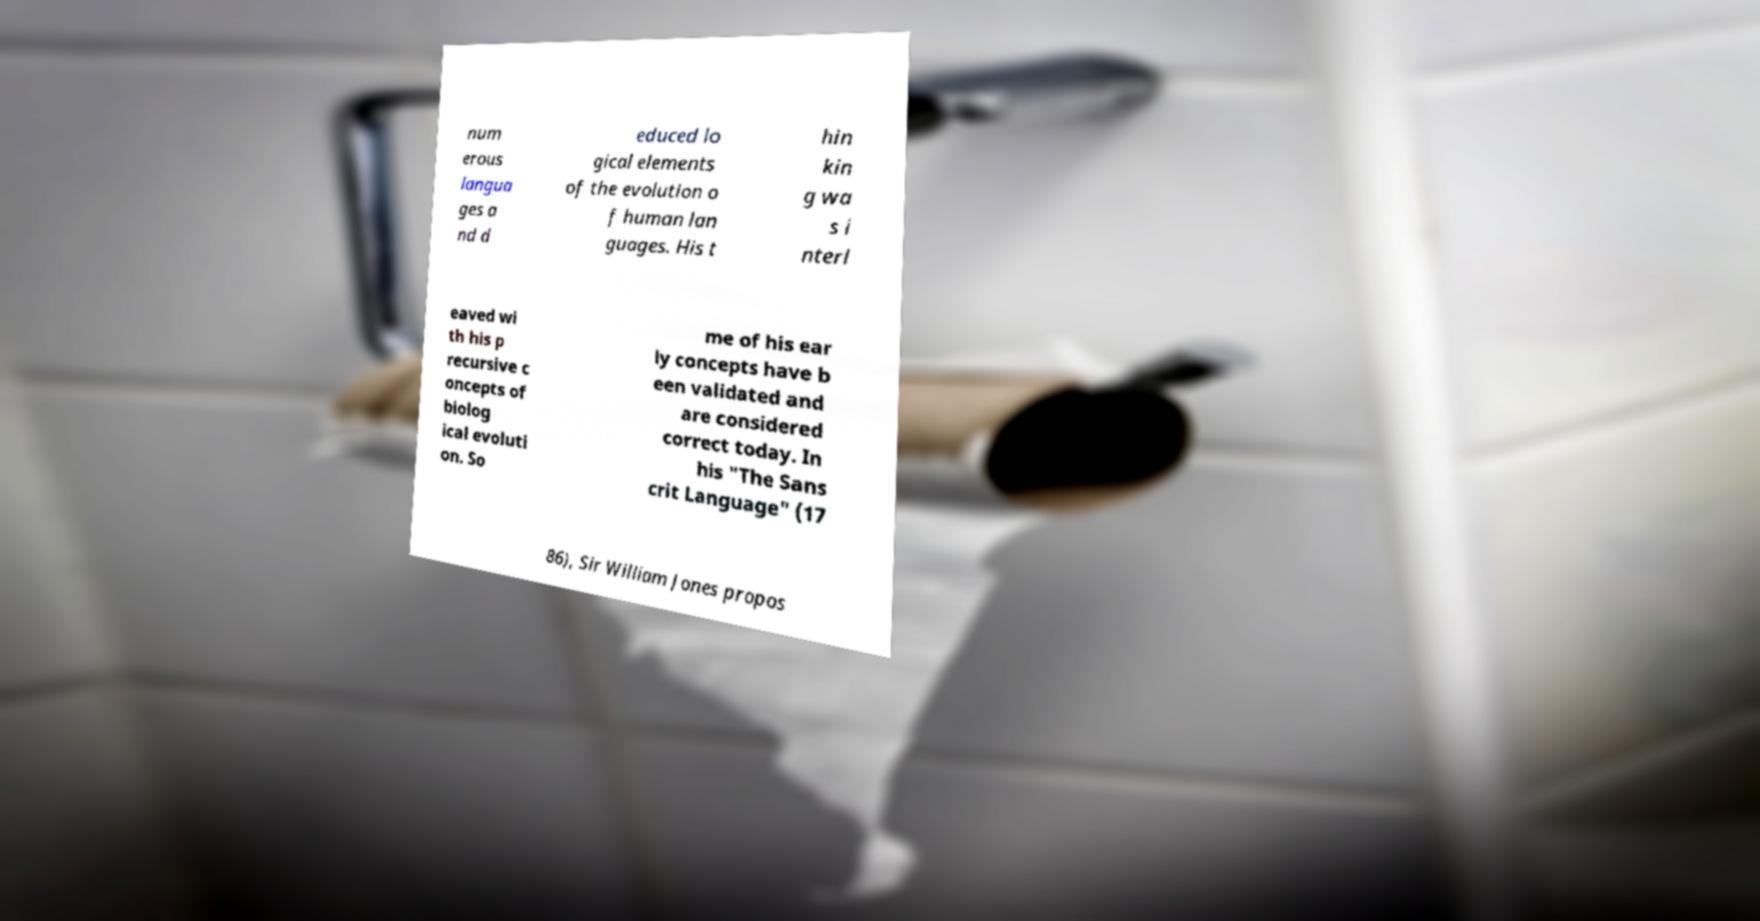For documentation purposes, I need the text within this image transcribed. Could you provide that? num erous langua ges a nd d educed lo gical elements of the evolution o f human lan guages. His t hin kin g wa s i nterl eaved wi th his p recursive c oncepts of biolog ical evoluti on. So me of his ear ly concepts have b een validated and are considered correct today. In his "The Sans crit Language" (17 86), Sir William Jones propos 